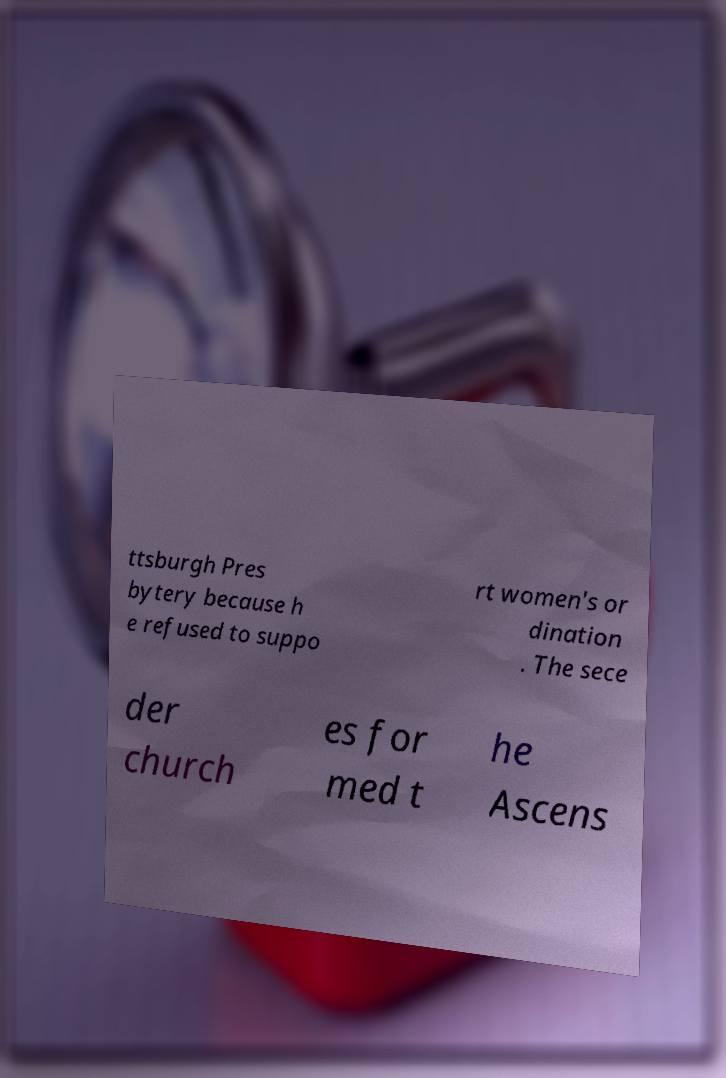Can you read and provide the text displayed in the image?This photo seems to have some interesting text. Can you extract and type it out for me? ttsburgh Pres bytery because h e refused to suppo rt women's or dination . The sece der church es for med t he Ascens 